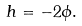<formula> <loc_0><loc_0><loc_500><loc_500>h = - 2 \phi .</formula> 